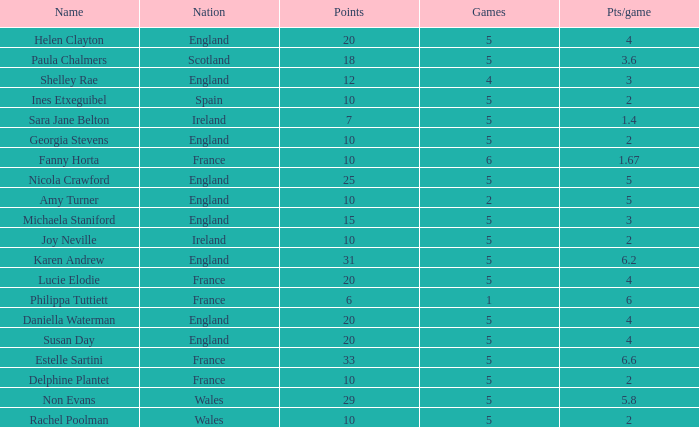Can you tell me the lowest Games that has the Pts/game larger than 1.4 and the Points of 20, and the Name of susan day? 5.0. 